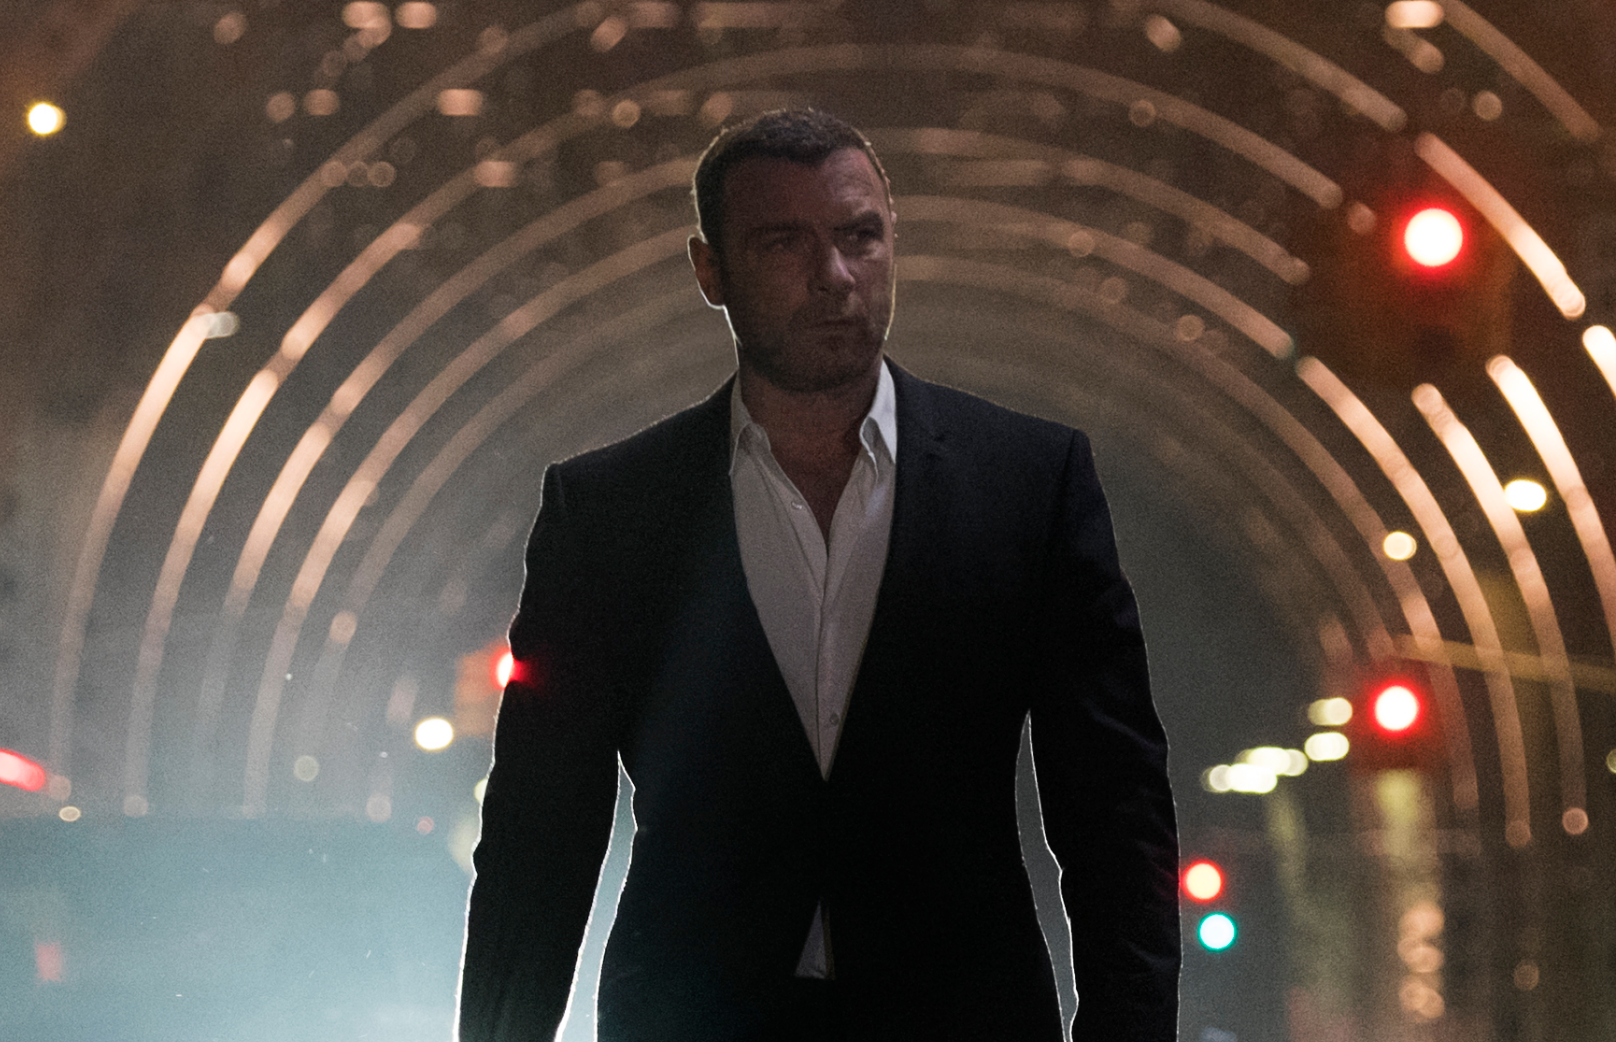What do the colors in the photo tell us about the time and place? The colors in the photo are mostly desaturated, with a dominance of blues and grays, suggesting a scene captured during night-time. The presence of red and green lights scattered in the background indicate traffic signals, placing the scene in a modern, urban context. The lighting appears artificial and is likely from street lamps or other city lights, underscoring the nighttime setting and possibly an after-hours moment. 